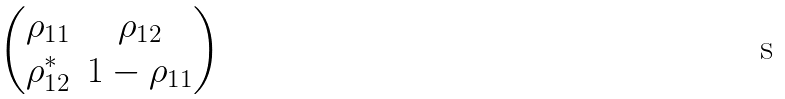Convert formula to latex. <formula><loc_0><loc_0><loc_500><loc_500>\begin{pmatrix} \rho _ { 1 1 } & \rho _ { 1 2 } \\ \rho _ { 1 2 } ^ { * } & 1 - \rho _ { 1 1 } \end{pmatrix}</formula> 